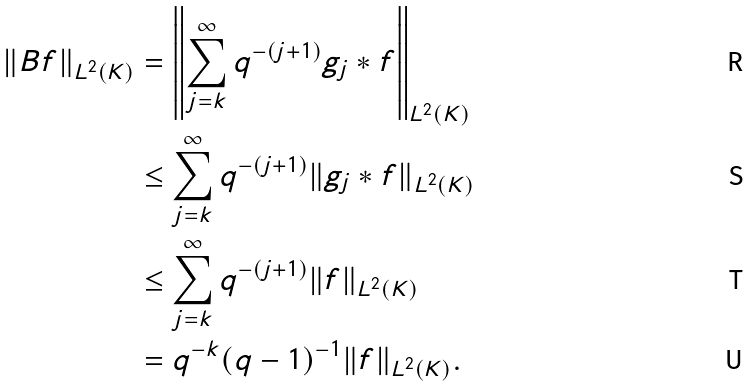<formula> <loc_0><loc_0><loc_500><loc_500>\| B f \| _ { L ^ { 2 } ( K ) } & = \left \| \sum _ { j = k } ^ { \infty } q ^ { - ( j + 1 ) } g _ { j } \ast f \right \| _ { L ^ { 2 } ( K ) } \\ & \leq \sum _ { j = k } ^ { \infty } q ^ { - ( j + 1 ) } \| g _ { j } \ast f \| _ { L ^ { 2 } ( K ) } \\ & \leq \sum _ { j = k } ^ { \infty } q ^ { - ( j + 1 ) } \| f \| _ { L ^ { 2 } ( K ) } \\ & = q ^ { - k } ( q - 1 ) ^ { - 1 } \| f \| _ { L ^ { 2 } ( K ) } .</formula> 